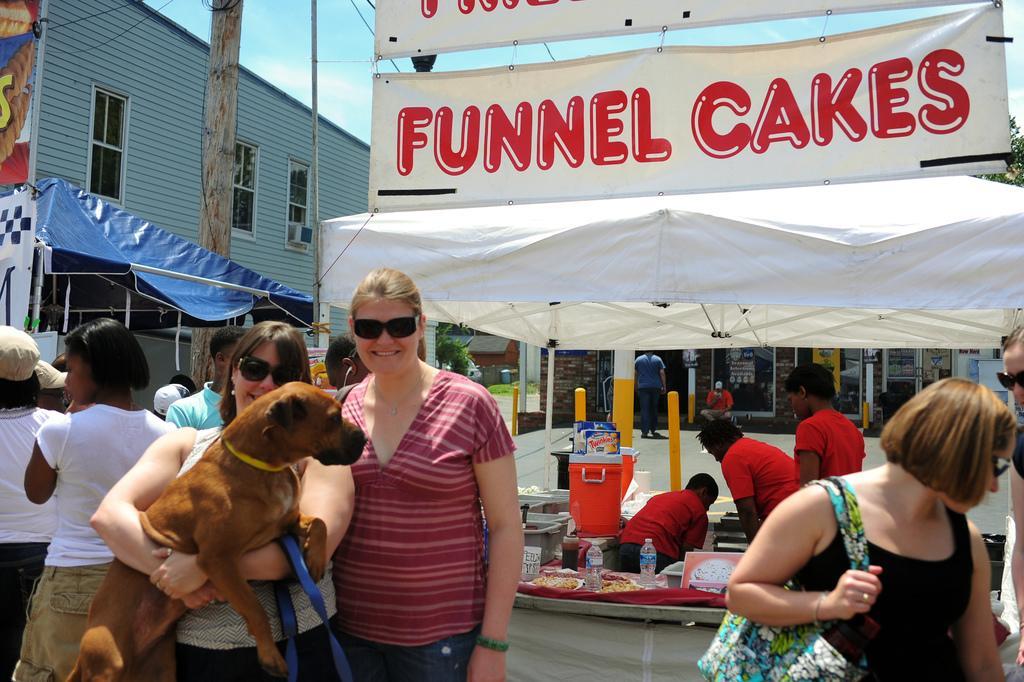In one or two sentences, can you explain what this image depicts? The image is outside of the city. In the image on left side there are woman wearing their goggles and one woman is holding a dog on her both hands. On right side there is a woman wearing a black dress is holding her hand bag. In background there are group of people walking and standing and we can also see some hoardings,building,trees,electric wires and sky is on top. 